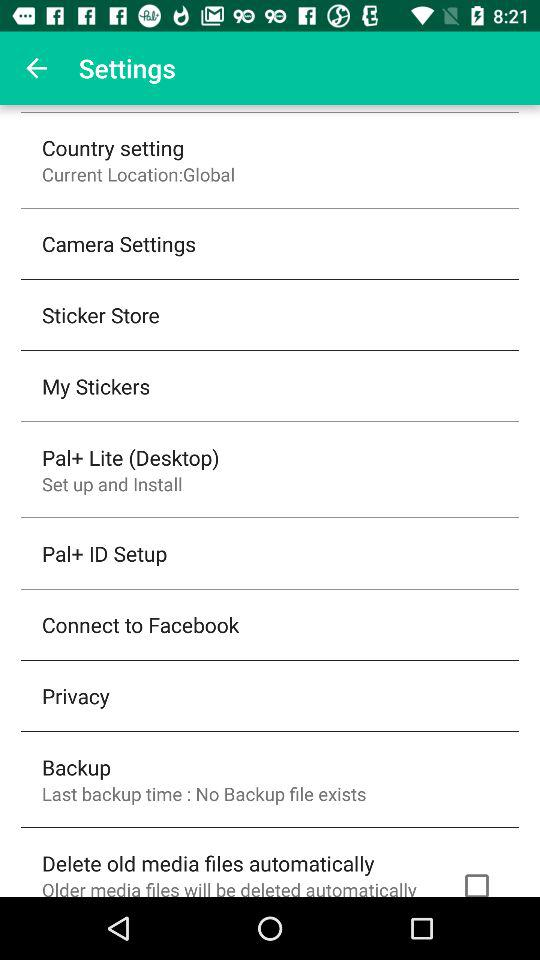What is the last backup time?
When the provided information is insufficient, respond with <no answer>. <no answer> 